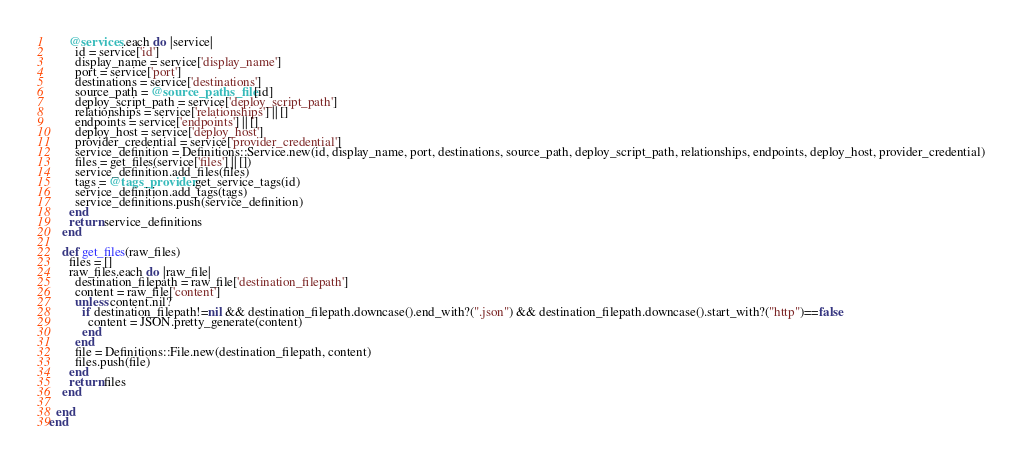Convert code to text. <code><loc_0><loc_0><loc_500><loc_500><_Ruby_>      @services.each do |service|
        id = service['id']
        display_name = service['display_name']
        port = service['port']
        destinations = service['destinations']
        source_path = @source_paths_file[id]
        deploy_script_path = service['deploy_script_path']
        relationships = service['relationships'] || []
        endpoints = service['endpoints'] || []
        deploy_host = service['deploy_host']
        provider_credential = service['provider_credential']	
        service_definition = Definitions::Service.new(id, display_name, port, destinations, source_path, deploy_script_path, relationships, endpoints, deploy_host, provider_credential)
        files = get_files(service['files'] || [])
        service_definition.add_files(files)
        tags = @tags_provider.get_service_tags(id)
        service_definition.add_tags(tags)
        service_definitions.push(service_definition)
      end
      return service_definitions
    end

    def get_files(raw_files)
      files = []
      raw_files.each do |raw_file|
        destination_filepath = raw_file['destination_filepath']
        content = raw_file['content']
        unless content.nil?
          if destination_filepath!=nil && destination_filepath.downcase().end_with?(".json") && destination_filepath.downcase().start_with?("http")==false
            content = JSON.pretty_generate(content)
          end
        end
        file = Definitions::File.new(destination_filepath, content)
        files.push(file)
      end
      return files
    end

  end
end</code> 